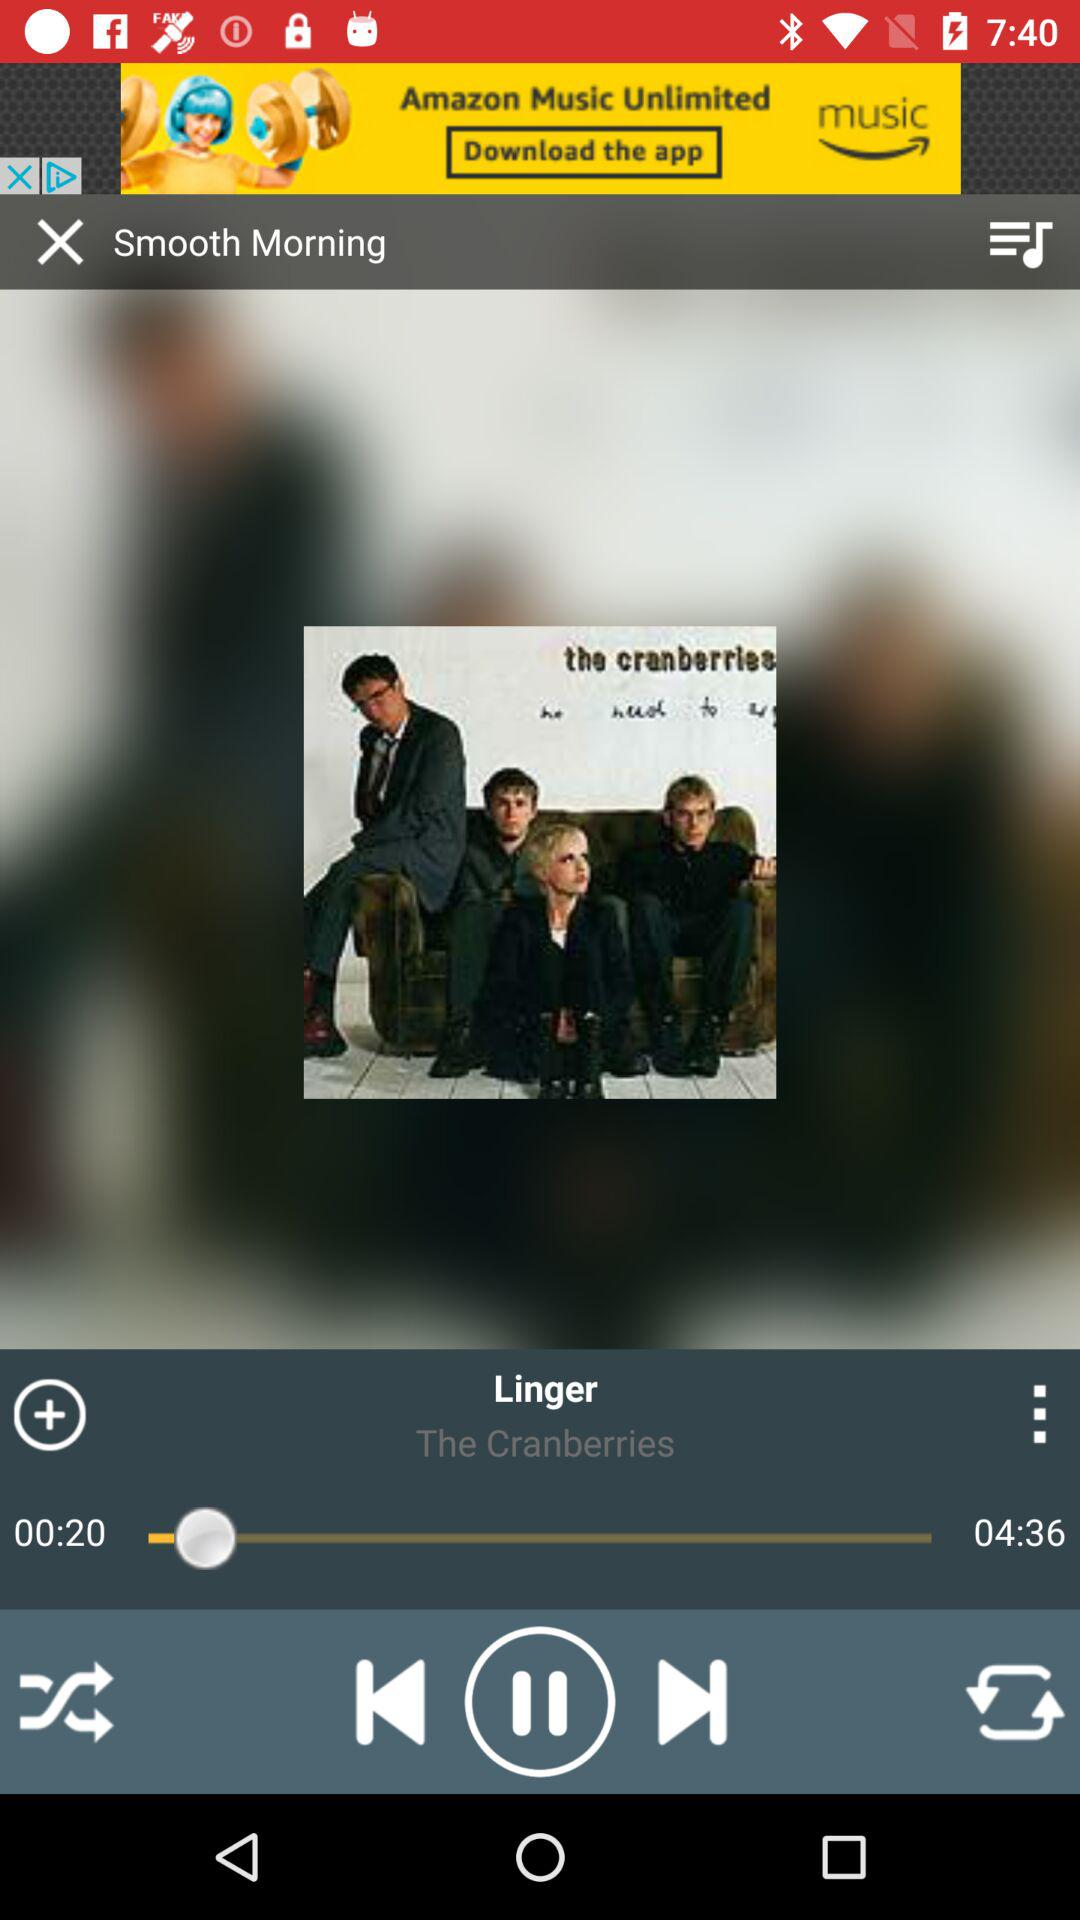What is the band name of the song? The band name of the song is "The Cranberries". 